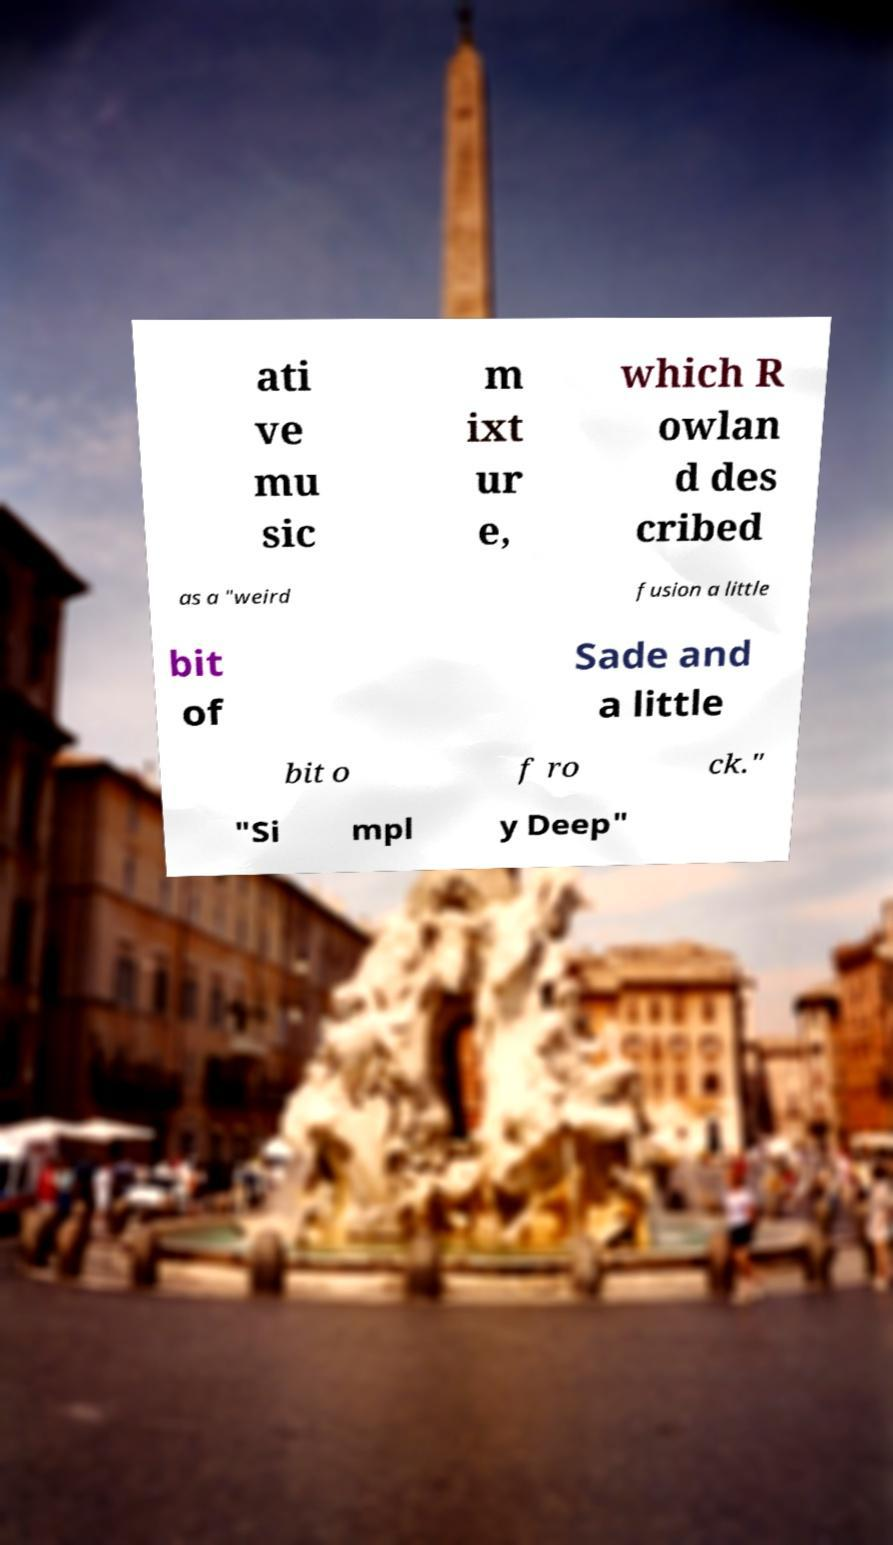Please identify and transcribe the text found in this image. ati ve mu sic m ixt ur e, which R owlan d des cribed as a "weird fusion a little bit of Sade and a little bit o f ro ck." "Si mpl y Deep" 